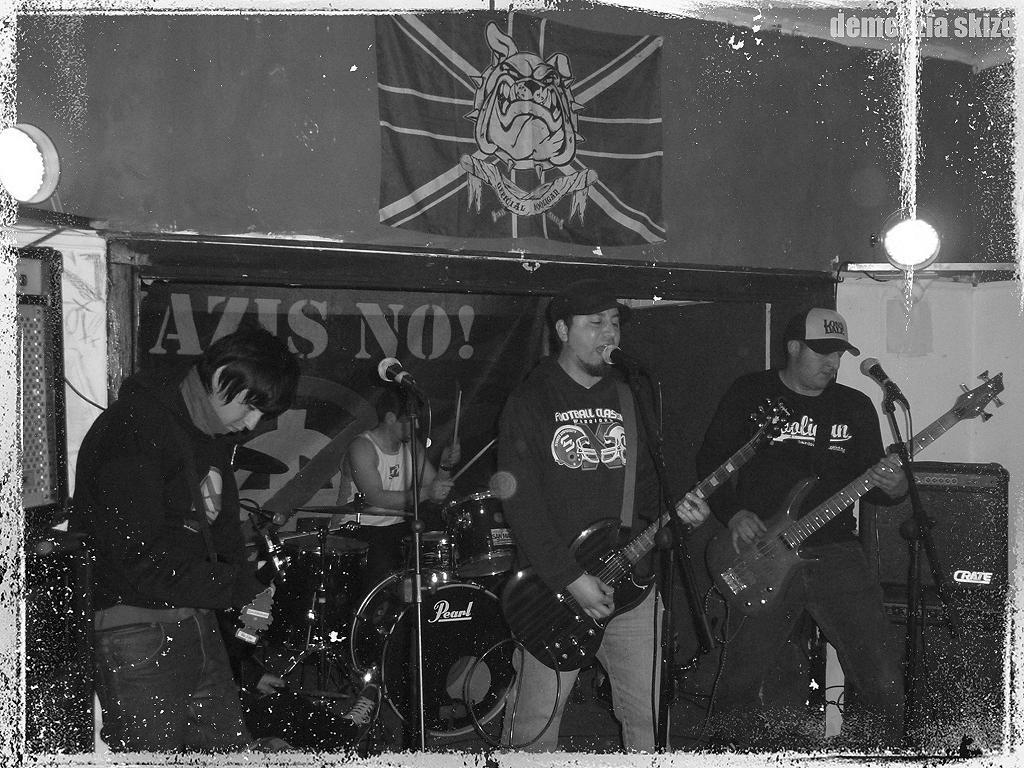Describe this image in one or two sentences. In this image In the middle there is a man he is playing guitar he wears cap, t shirt and trouser. On the right there is a man he wears t shirt, cap and trouser he is playing guitar. On the left there is a man. In the back ground there is a man, dreams he is playing drums, mic, poster and light. 